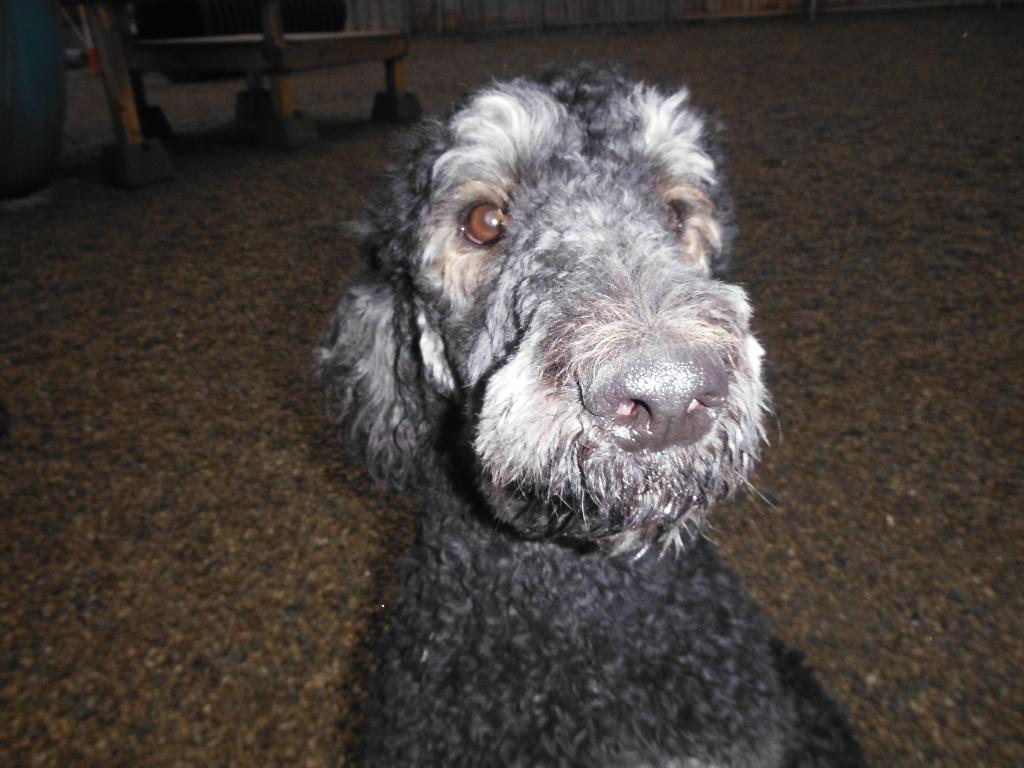What type of animal is in the image? There is a dog in the image. What color is the dog? The dog is black in color. What is at the bottom of the image? There is a floor at the bottom of the image. What can be seen in the background of the image? There is a curtain in the background of the image. What is visible to the left of the image? There are wooden sticks visible to the left of the image. What type of plants can be seen growing in the morning in the image? There are no plants visible in the image, and the time of day is not mentioned, so it is not possible to answer this question. 